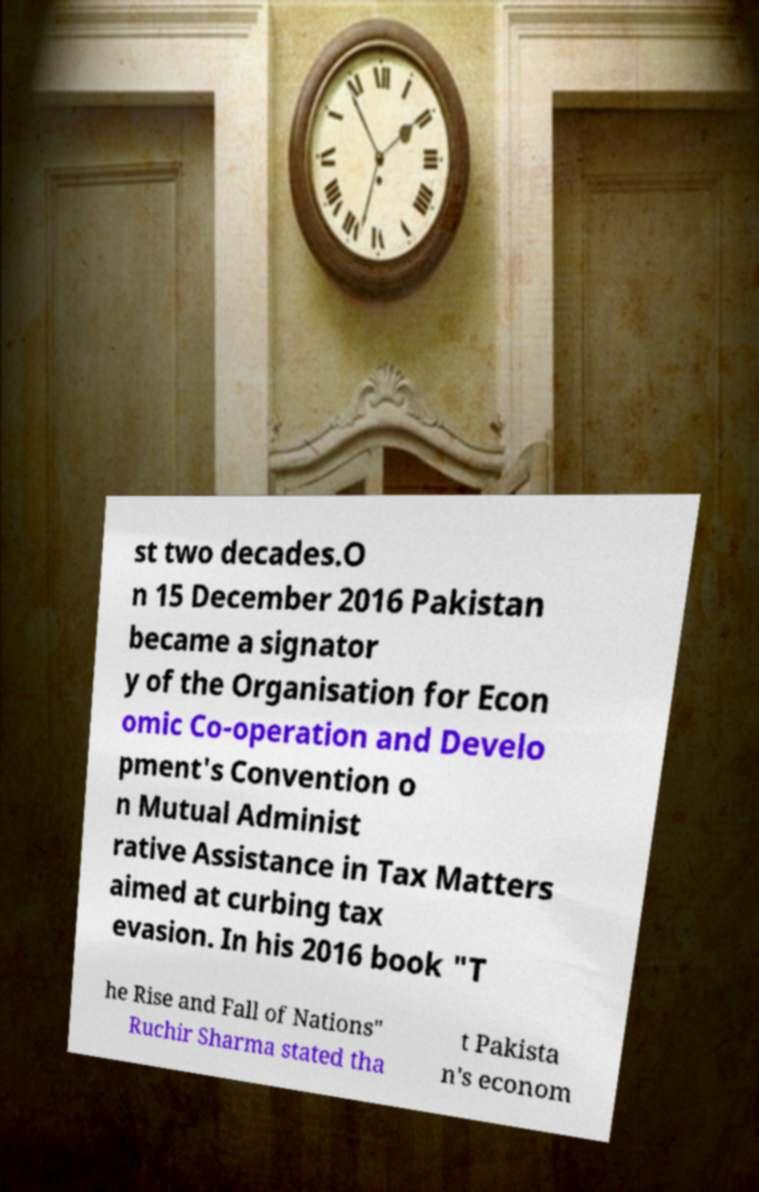Can you accurately transcribe the text from the provided image for me? st two decades.O n 15 December 2016 Pakistan became a signator y of the Organisation for Econ omic Co-operation and Develo pment's Convention o n Mutual Administ rative Assistance in Tax Matters aimed at curbing tax evasion. In his 2016 book "T he Rise and Fall of Nations" Ruchir Sharma stated tha t Pakista n's econom 